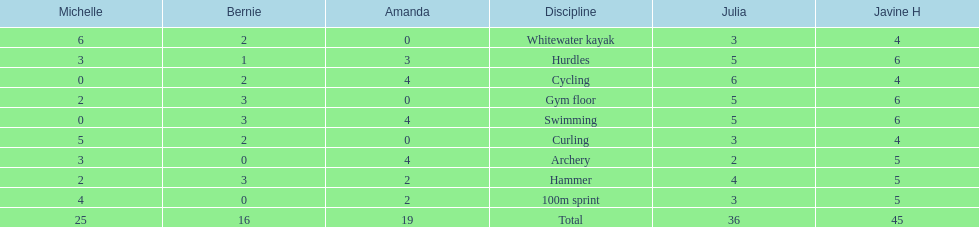What is the first discipline listed on this chart? Whitewater kayak. 